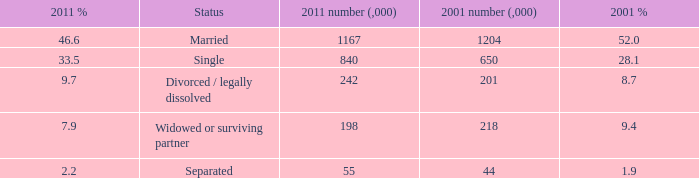What is the 2001 % for the status widowed or surviving partner? 9.4. Could you parse the entire table? {'header': ['2011 %', 'Status', '2011 number (,000)', '2001 number (,000)', '2001 %'], 'rows': [['46.6', 'Married', '1167', '1204', '52.0'], ['33.5', 'Single', '840', '650', '28.1'], ['9.7', 'Divorced / legally dissolved', '242', '201', '8.7'], ['7.9', 'Widowed or surviving partner', '198', '218', '9.4'], ['2.2', 'Separated', '55', '44', '1.9']]} 